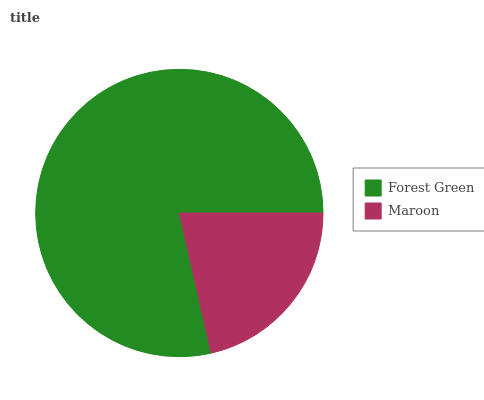Is Maroon the minimum?
Answer yes or no. Yes. Is Forest Green the maximum?
Answer yes or no. Yes. Is Maroon the maximum?
Answer yes or no. No. Is Forest Green greater than Maroon?
Answer yes or no. Yes. Is Maroon less than Forest Green?
Answer yes or no. Yes. Is Maroon greater than Forest Green?
Answer yes or no. No. Is Forest Green less than Maroon?
Answer yes or no. No. Is Forest Green the high median?
Answer yes or no. Yes. Is Maroon the low median?
Answer yes or no. Yes. Is Maroon the high median?
Answer yes or no. No. Is Forest Green the low median?
Answer yes or no. No. 